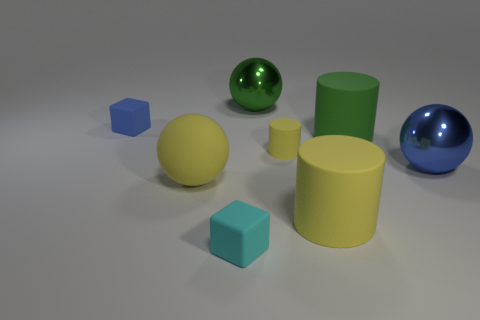Add 2 yellow metal balls. How many objects exist? 10 Subtract all cylinders. How many objects are left? 5 Add 7 small blue matte things. How many small blue matte things exist? 8 Subtract 0 blue cylinders. How many objects are left? 8 Subtract all red blocks. Subtract all blue cubes. How many objects are left? 7 Add 3 tiny blue rubber objects. How many tiny blue rubber objects are left? 4 